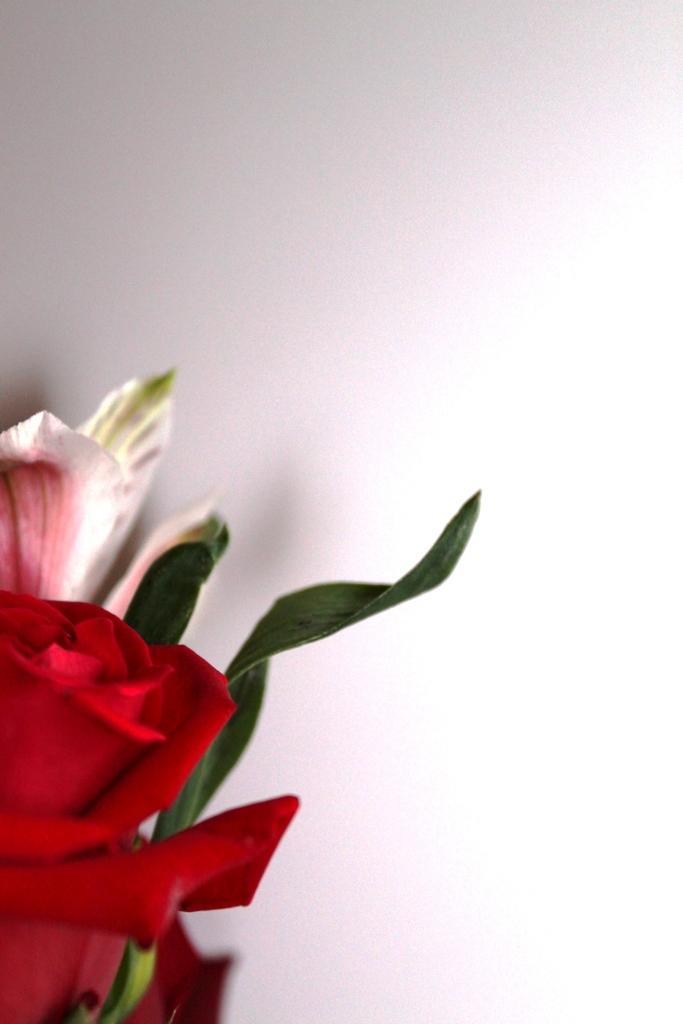In one or two sentences, can you explain what this image depicts? In this image we can see a flower and leaves. 